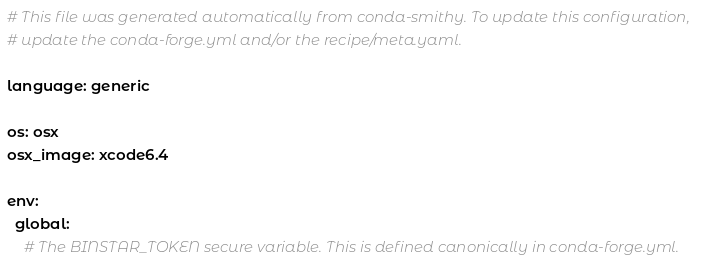Convert code to text. <code><loc_0><loc_0><loc_500><loc_500><_YAML_># This file was generated automatically from conda-smithy. To update this configuration,
# update the conda-forge.yml and/or the recipe/meta.yaml.

language: generic

os: osx
osx_image: xcode6.4

env:
  global:
    # The BINSTAR_TOKEN secure variable. This is defined canonically in conda-forge.yml.</code> 